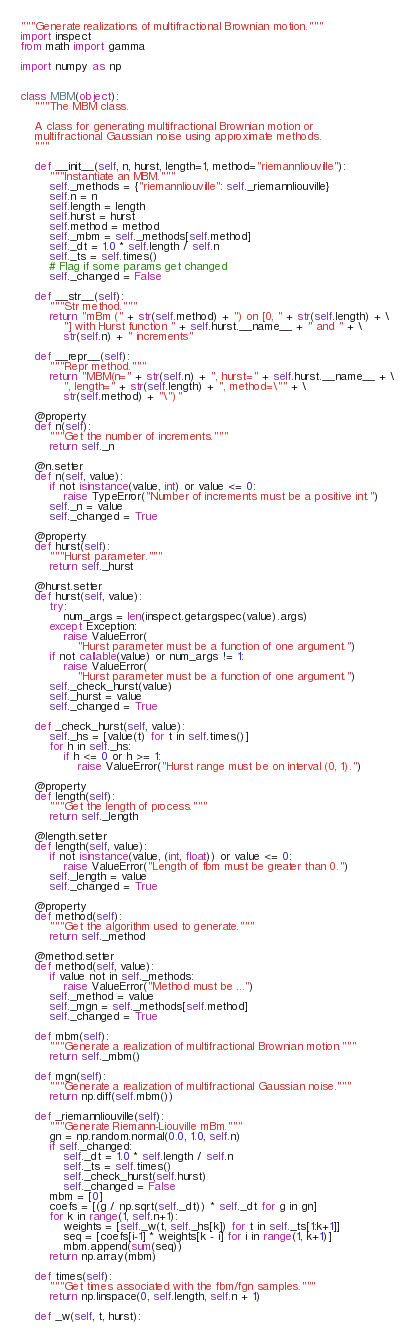Convert code to text. <code><loc_0><loc_0><loc_500><loc_500><_Python_>"""Generate realizations of multifractional Brownian motion."""
import inspect
from math import gamma

import numpy as np


class MBM(object):
    """The MBM class.

    A class for generating multifractional Brownian motion or
    multifractional Gaussian noise using approximate methods.
    """

    def __init__(self, n, hurst, length=1, method="riemannliouville"):
        """Instantiate an MBM."""
        self._methods = {"riemannliouville": self._riemannliouville}
        self.n = n
        self.length = length
        self.hurst = hurst
        self.method = method
        self._mbm = self._methods[self.method]
        self._dt = 1.0 * self.length / self.n
        self._ts = self.times()
        # Flag if some params get changed
        self._changed = False

    def __str__(self):
        """Str method."""
        return "mBm (" + str(self.method) + ") on [0, " + str(self.length) + \
            "] with Hurst function " + self.hurst.__name__ + " and " + \
            str(self.n) + " increments"

    def __repr__(self):
        """Repr method."""
        return "MBM(n=" + str(self.n) + ", hurst=" + self.hurst.__name__ + \
            ", length=" + str(self.length) + ", method=\"" + \
            str(self.method) + "\")"

    @property
    def n(self):
        """Get the number of increments."""
        return self._n

    @n.setter
    def n(self, value):
        if not isinstance(value, int) or value <= 0:
            raise TypeError("Number of increments must be a positive int.")
        self._n = value
        self._changed = True

    @property
    def hurst(self):
        """Hurst parameter."""
        return self._hurst

    @hurst.setter
    def hurst(self, value):
        try:
            num_args = len(inspect.getargspec(value).args)
        except Exception:
            raise ValueError(
                "Hurst parameter must be a function of one argument.")
        if not callable(value) or num_args != 1:
            raise ValueError(
                "Hurst parameter must be a function of one argument.")
        self._check_hurst(value)
        self._hurst = value
        self._changed = True

    def _check_hurst(self, value):
        self._hs = [value(t) for t in self.times()]
        for h in self._hs:
            if h <= 0 or h >= 1:
                raise ValueError("Hurst range must be on interval (0, 1).")

    @property
    def length(self):
        """Get the length of process."""
        return self._length

    @length.setter
    def length(self, value):
        if not isinstance(value, (int, float)) or value <= 0:
            raise ValueError("Length of fbm must be greater than 0.")
        self._length = value
        self._changed = True

    @property
    def method(self):
        """Get the algorithm used to generate."""
        return self._method

    @method.setter
    def method(self, value):
        if value not in self._methods:
            raise ValueError("Method must be ...")
        self._method = value
        self._mgn = self._methods[self.method]
        self._changed = True

    def mbm(self):
        """Generate a realization of multifractional Brownian motion."""
        return self._mbm()

    def mgn(self):
        """Generate a realization of multifractional Gaussian noise."""
        return np.diff(self.mbm())

    def _riemannliouville(self):
        """Generate Riemann-Liouville mBm."""
        gn = np.random.normal(0.0, 1.0, self.n)
        if self._changed:
            self._dt = 1.0 * self.length / self.n
            self._ts = self.times()
            self._check_hurst(self.hurst)
            self._changed = False
        mbm = [0]
        coefs = [(g / np.sqrt(self._dt)) * self._dt for g in gn]
        for k in range(1, self.n+1):
            weights = [self._w(t, self._hs[k]) for t in self._ts[1:k+1]]
            seq = [coefs[i-1] * weights[k - i] for i in range(1, k+1)]
            mbm.append(sum(seq))
        return np.array(mbm)

    def times(self):
        """Get times associated with the fbm/fgn samples."""
        return np.linspace(0, self.length, self.n + 1)

    def _w(self, t, hurst):</code> 